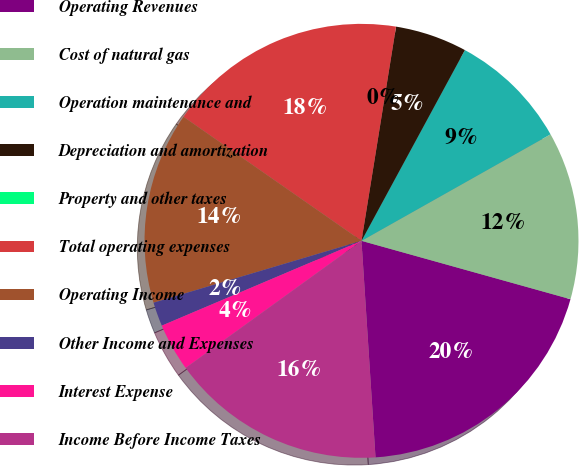<chart> <loc_0><loc_0><loc_500><loc_500><pie_chart><fcel>Operating Revenues<fcel>Cost of natural gas<fcel>Operation maintenance and<fcel>Depreciation and amortization<fcel>Property and other taxes<fcel>Total operating expenses<fcel>Operating Income<fcel>Other Income and Expenses<fcel>Interest Expense<fcel>Income Before Income Taxes<nl><fcel>19.64%<fcel>12.5%<fcel>8.93%<fcel>5.36%<fcel>0.0%<fcel>17.86%<fcel>14.29%<fcel>1.79%<fcel>3.57%<fcel>16.07%<nl></chart> 